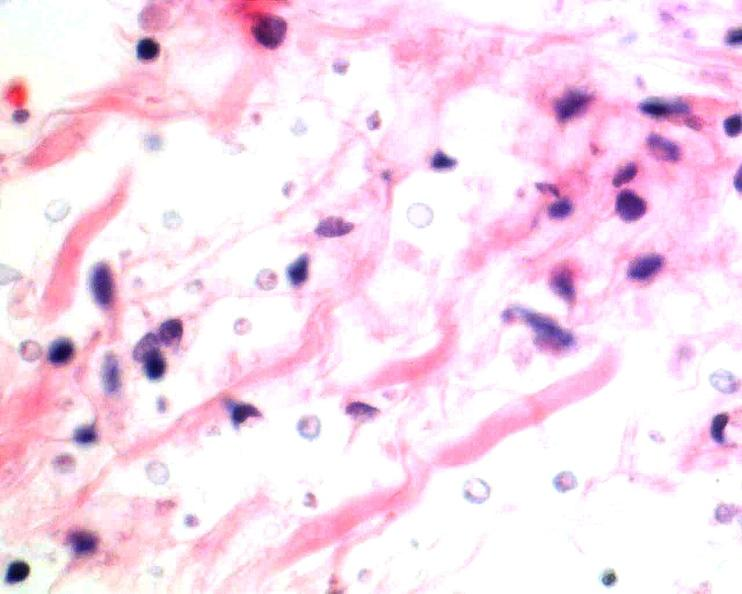s pinworm present?
Answer the question using a single word or phrase. No 